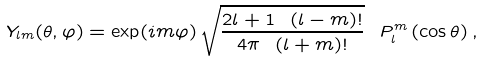Convert formula to latex. <formula><loc_0><loc_0><loc_500><loc_500>Y _ { l m } ( \theta , \varphi ) = \exp ( i m \varphi ) \, \sqrt { \frac { 2 l + 1 \ ( l - m ) ! } { 4 \pi \ ( l + m ) ! } } \ P _ { l } ^ { m } \left ( \cos \theta \right ) ,</formula> 